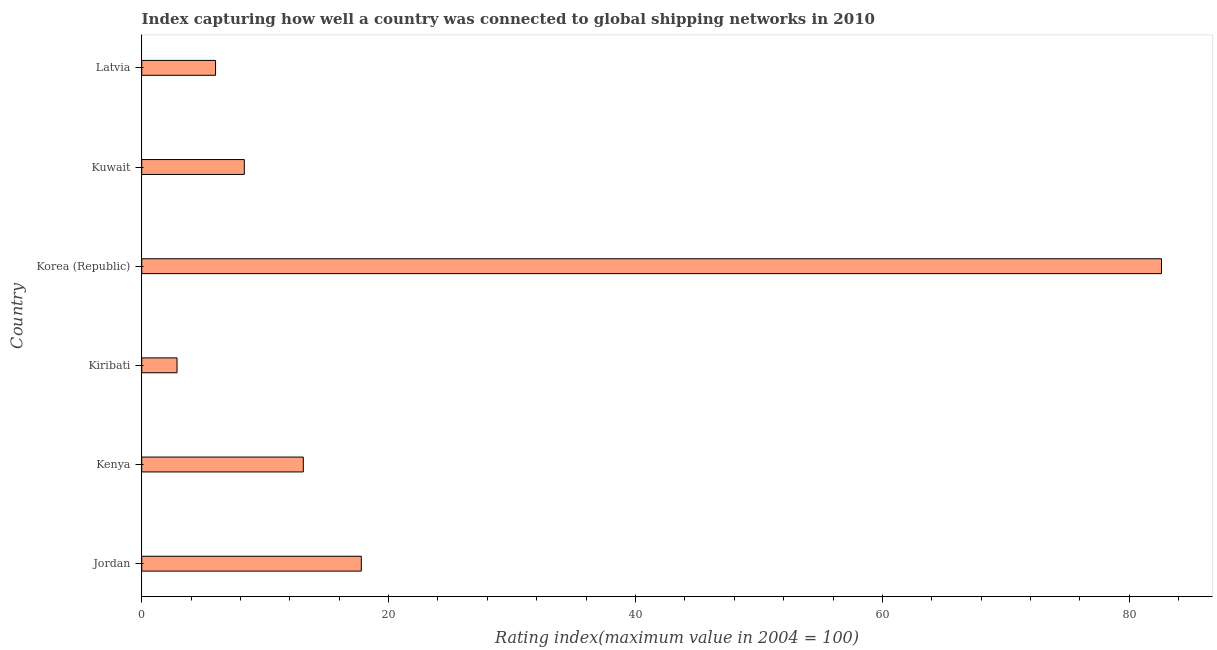What is the title of the graph?
Make the answer very short. Index capturing how well a country was connected to global shipping networks in 2010. What is the label or title of the X-axis?
Give a very brief answer. Rating index(maximum value in 2004 = 100). What is the liner shipping connectivity index in Kenya?
Make the answer very short. 13.09. Across all countries, what is the maximum liner shipping connectivity index?
Offer a very short reply. 82.61. Across all countries, what is the minimum liner shipping connectivity index?
Ensure brevity in your answer.  2.86. In which country was the liner shipping connectivity index maximum?
Make the answer very short. Korea (Republic). In which country was the liner shipping connectivity index minimum?
Your answer should be very brief. Kiribati. What is the sum of the liner shipping connectivity index?
Your response must be concise. 130.64. What is the difference between the liner shipping connectivity index in Kiribati and Korea (Republic)?
Your answer should be compact. -79.75. What is the average liner shipping connectivity index per country?
Ensure brevity in your answer.  21.77. What is the median liner shipping connectivity index?
Give a very brief answer. 10.7. In how many countries, is the liner shipping connectivity index greater than 44 ?
Offer a very short reply. 1. What is the ratio of the liner shipping connectivity index in Jordan to that in Kiribati?
Make the answer very short. 6.22. Is the liner shipping connectivity index in Jordan less than that in Kenya?
Provide a short and direct response. No. What is the difference between the highest and the second highest liner shipping connectivity index?
Offer a very short reply. 64.82. Is the sum of the liner shipping connectivity index in Jordan and Kiribati greater than the maximum liner shipping connectivity index across all countries?
Offer a terse response. No. What is the difference between the highest and the lowest liner shipping connectivity index?
Provide a succinct answer. 79.75. In how many countries, is the liner shipping connectivity index greater than the average liner shipping connectivity index taken over all countries?
Give a very brief answer. 1. How many bars are there?
Your response must be concise. 6. How many countries are there in the graph?
Your answer should be very brief. 6. What is the difference between two consecutive major ticks on the X-axis?
Ensure brevity in your answer.  20. Are the values on the major ticks of X-axis written in scientific E-notation?
Offer a terse response. No. What is the Rating index(maximum value in 2004 = 100) in Jordan?
Offer a very short reply. 17.79. What is the Rating index(maximum value in 2004 = 100) in Kenya?
Your response must be concise. 13.09. What is the Rating index(maximum value in 2004 = 100) of Kiribati?
Your answer should be compact. 2.86. What is the Rating index(maximum value in 2004 = 100) of Korea (Republic)?
Offer a very short reply. 82.61. What is the Rating index(maximum value in 2004 = 100) of Kuwait?
Offer a terse response. 8.31. What is the Rating index(maximum value in 2004 = 100) in Latvia?
Give a very brief answer. 5.98. What is the difference between the Rating index(maximum value in 2004 = 100) in Jordan and Kenya?
Provide a short and direct response. 4.7. What is the difference between the Rating index(maximum value in 2004 = 100) in Jordan and Kiribati?
Offer a very short reply. 14.93. What is the difference between the Rating index(maximum value in 2004 = 100) in Jordan and Korea (Republic)?
Make the answer very short. -64.82. What is the difference between the Rating index(maximum value in 2004 = 100) in Jordan and Kuwait?
Give a very brief answer. 9.48. What is the difference between the Rating index(maximum value in 2004 = 100) in Jordan and Latvia?
Offer a very short reply. 11.81. What is the difference between the Rating index(maximum value in 2004 = 100) in Kenya and Kiribati?
Provide a succinct answer. 10.23. What is the difference between the Rating index(maximum value in 2004 = 100) in Kenya and Korea (Republic)?
Your answer should be very brief. -69.52. What is the difference between the Rating index(maximum value in 2004 = 100) in Kenya and Kuwait?
Your answer should be compact. 4.78. What is the difference between the Rating index(maximum value in 2004 = 100) in Kenya and Latvia?
Your answer should be compact. 7.11. What is the difference between the Rating index(maximum value in 2004 = 100) in Kiribati and Korea (Republic)?
Give a very brief answer. -79.75. What is the difference between the Rating index(maximum value in 2004 = 100) in Kiribati and Kuwait?
Your response must be concise. -5.45. What is the difference between the Rating index(maximum value in 2004 = 100) in Kiribati and Latvia?
Offer a terse response. -3.12. What is the difference between the Rating index(maximum value in 2004 = 100) in Korea (Republic) and Kuwait?
Offer a terse response. 74.3. What is the difference between the Rating index(maximum value in 2004 = 100) in Korea (Republic) and Latvia?
Your answer should be very brief. 76.63. What is the difference between the Rating index(maximum value in 2004 = 100) in Kuwait and Latvia?
Your answer should be very brief. 2.33. What is the ratio of the Rating index(maximum value in 2004 = 100) in Jordan to that in Kenya?
Make the answer very short. 1.36. What is the ratio of the Rating index(maximum value in 2004 = 100) in Jordan to that in Kiribati?
Your answer should be compact. 6.22. What is the ratio of the Rating index(maximum value in 2004 = 100) in Jordan to that in Korea (Republic)?
Your answer should be very brief. 0.21. What is the ratio of the Rating index(maximum value in 2004 = 100) in Jordan to that in Kuwait?
Offer a very short reply. 2.14. What is the ratio of the Rating index(maximum value in 2004 = 100) in Jordan to that in Latvia?
Make the answer very short. 2.98. What is the ratio of the Rating index(maximum value in 2004 = 100) in Kenya to that in Kiribati?
Give a very brief answer. 4.58. What is the ratio of the Rating index(maximum value in 2004 = 100) in Kenya to that in Korea (Republic)?
Provide a short and direct response. 0.16. What is the ratio of the Rating index(maximum value in 2004 = 100) in Kenya to that in Kuwait?
Your response must be concise. 1.57. What is the ratio of the Rating index(maximum value in 2004 = 100) in Kenya to that in Latvia?
Offer a very short reply. 2.19. What is the ratio of the Rating index(maximum value in 2004 = 100) in Kiribati to that in Korea (Republic)?
Keep it short and to the point. 0.04. What is the ratio of the Rating index(maximum value in 2004 = 100) in Kiribati to that in Kuwait?
Offer a very short reply. 0.34. What is the ratio of the Rating index(maximum value in 2004 = 100) in Kiribati to that in Latvia?
Ensure brevity in your answer.  0.48. What is the ratio of the Rating index(maximum value in 2004 = 100) in Korea (Republic) to that in Kuwait?
Offer a terse response. 9.94. What is the ratio of the Rating index(maximum value in 2004 = 100) in Korea (Republic) to that in Latvia?
Provide a short and direct response. 13.81. What is the ratio of the Rating index(maximum value in 2004 = 100) in Kuwait to that in Latvia?
Your answer should be compact. 1.39. 